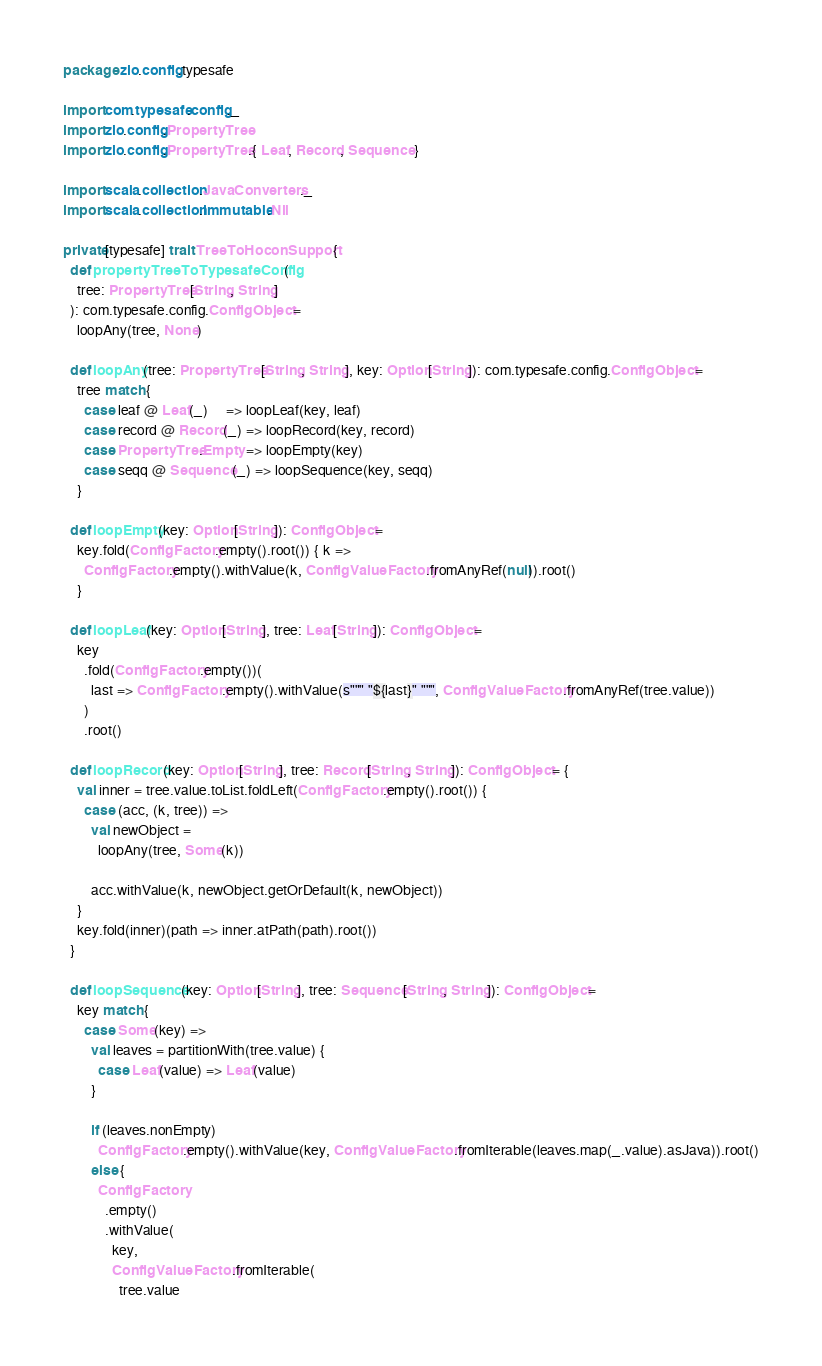<code> <loc_0><loc_0><loc_500><loc_500><_Scala_>package zio.config.typesafe

import com.typesafe.config._
import zio.config.PropertyTree
import zio.config.PropertyTree.{ Leaf, Record, Sequence }

import scala.collection.JavaConverters._
import scala.collection.immutable.Nil

private[typesafe] trait TreeToHoconSupport {
  def propertyTreeToTypesafeConfig(
    tree: PropertyTree[String, String]
  ): com.typesafe.config.ConfigObject =
    loopAny(tree, None)

  def loopAny(tree: PropertyTree[String, String], key: Option[String]): com.typesafe.config.ConfigObject =
    tree match {
      case leaf @ Leaf(_)     => loopLeaf(key, leaf)
      case record @ Record(_) => loopRecord(key, record)
      case PropertyTree.Empty => loopEmpty(key)
      case seqq @ Sequence(_) => loopSequence(key, seqq)
    }

  def loopEmpty(key: Option[String]): ConfigObject =
    key.fold(ConfigFactory.empty().root()) { k =>
      ConfigFactory.empty().withValue(k, ConfigValueFactory.fromAnyRef(null)).root()
    }

  def loopLeaf(key: Option[String], tree: Leaf[String]): ConfigObject =
    key
      .fold(ConfigFactory.empty())(
        last => ConfigFactory.empty().withValue(s""" "${last}" """, ConfigValueFactory.fromAnyRef(tree.value))
      )
      .root()

  def loopRecord(key: Option[String], tree: Record[String, String]): ConfigObject = {
    val inner = tree.value.toList.foldLeft(ConfigFactory.empty().root()) {
      case (acc, (k, tree)) =>
        val newObject =
          loopAny(tree, Some(k))

        acc.withValue(k, newObject.getOrDefault(k, newObject))
    }
    key.fold(inner)(path => inner.atPath(path).root())
  }

  def loopSequence(key: Option[String], tree: Sequence[String, String]): ConfigObject =
    key match {
      case Some(key) =>
        val leaves = partitionWith(tree.value) {
          case Leaf(value) => Leaf(value)
        }

        if (leaves.nonEmpty)
          ConfigFactory.empty().withValue(key, ConfigValueFactory.fromIterable(leaves.map(_.value).asJava)).root()
        else {
          ConfigFactory
            .empty()
            .withValue(
              key,
              ConfigValueFactory.fromIterable(
                tree.value</code> 